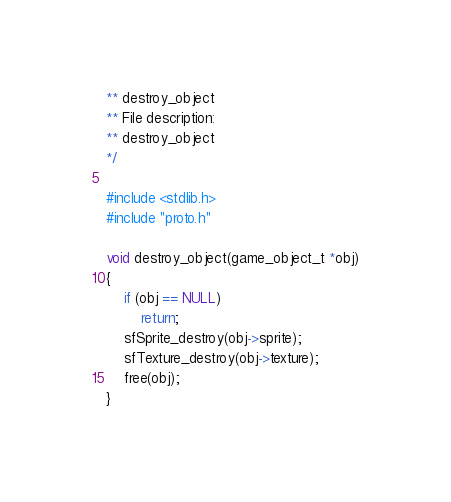Convert code to text. <code><loc_0><loc_0><loc_500><loc_500><_C_>** destroy_object
** File description:
** destroy_object
*/

#include <stdlib.h>
#include "proto.h"

void destroy_object(game_object_t *obj)
{
	if (obj == NULL)
		return;
	sfSprite_destroy(obj->sprite);
	sfTexture_destroy(obj->texture);
	free(obj);
}
</code> 